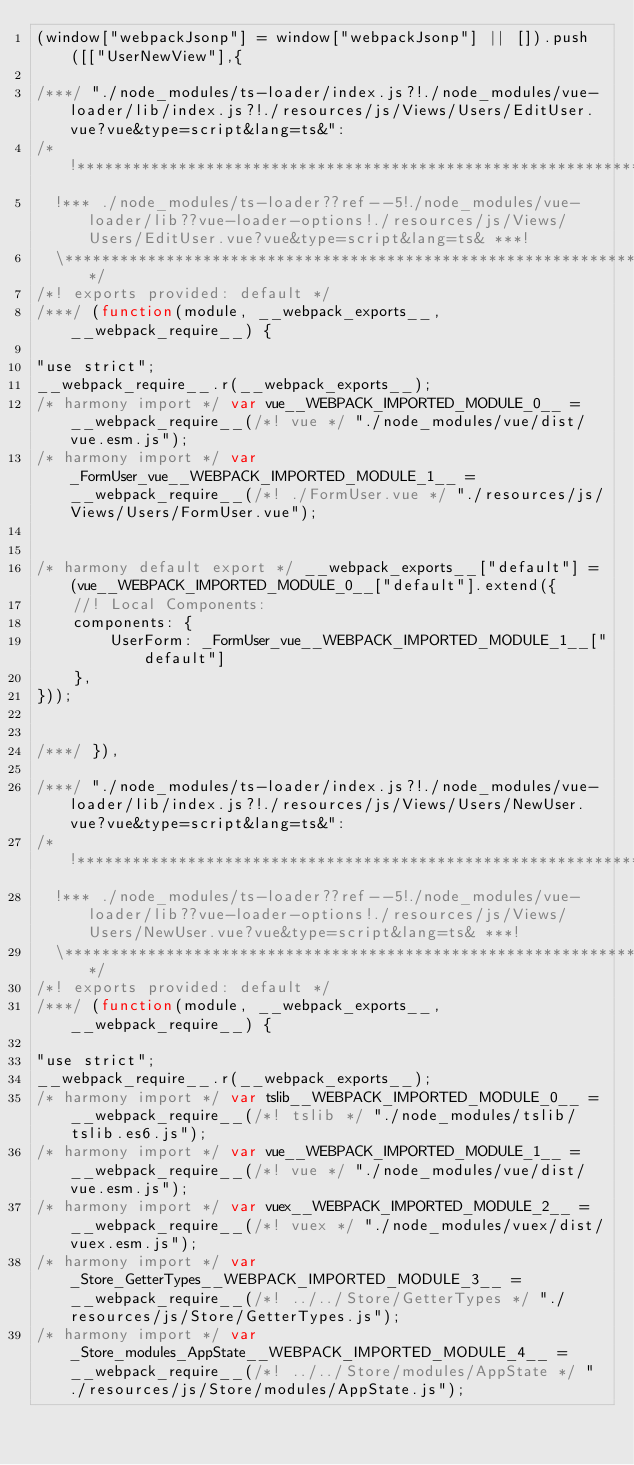Convert code to text. <code><loc_0><loc_0><loc_500><loc_500><_JavaScript_>(window["webpackJsonp"] = window["webpackJsonp"] || []).push([["UserNewView"],{

/***/ "./node_modules/ts-loader/index.js?!./node_modules/vue-loader/lib/index.js?!./resources/js/Views/Users/EditUser.vue?vue&type=script&lang=ts&":
/*!***********************************************************************************************************************************************************!*\
  !*** ./node_modules/ts-loader??ref--5!./node_modules/vue-loader/lib??vue-loader-options!./resources/js/Views/Users/EditUser.vue?vue&type=script&lang=ts& ***!
  \***********************************************************************************************************************************************************/
/*! exports provided: default */
/***/ (function(module, __webpack_exports__, __webpack_require__) {

"use strict";
__webpack_require__.r(__webpack_exports__);
/* harmony import */ var vue__WEBPACK_IMPORTED_MODULE_0__ = __webpack_require__(/*! vue */ "./node_modules/vue/dist/vue.esm.js");
/* harmony import */ var _FormUser_vue__WEBPACK_IMPORTED_MODULE_1__ = __webpack_require__(/*! ./FormUser.vue */ "./resources/js/Views/Users/FormUser.vue");


/* harmony default export */ __webpack_exports__["default"] = (vue__WEBPACK_IMPORTED_MODULE_0__["default"].extend({
    //! Local Components: 
    components: {
        UserForm: _FormUser_vue__WEBPACK_IMPORTED_MODULE_1__["default"]
    },
}));


/***/ }),

/***/ "./node_modules/ts-loader/index.js?!./node_modules/vue-loader/lib/index.js?!./resources/js/Views/Users/NewUser.vue?vue&type=script&lang=ts&":
/*!**********************************************************************************************************************************************************!*\
  !*** ./node_modules/ts-loader??ref--5!./node_modules/vue-loader/lib??vue-loader-options!./resources/js/Views/Users/NewUser.vue?vue&type=script&lang=ts& ***!
  \**********************************************************************************************************************************************************/
/*! exports provided: default */
/***/ (function(module, __webpack_exports__, __webpack_require__) {

"use strict";
__webpack_require__.r(__webpack_exports__);
/* harmony import */ var tslib__WEBPACK_IMPORTED_MODULE_0__ = __webpack_require__(/*! tslib */ "./node_modules/tslib/tslib.es6.js");
/* harmony import */ var vue__WEBPACK_IMPORTED_MODULE_1__ = __webpack_require__(/*! vue */ "./node_modules/vue/dist/vue.esm.js");
/* harmony import */ var vuex__WEBPACK_IMPORTED_MODULE_2__ = __webpack_require__(/*! vuex */ "./node_modules/vuex/dist/vuex.esm.js");
/* harmony import */ var _Store_GetterTypes__WEBPACK_IMPORTED_MODULE_3__ = __webpack_require__(/*! ../../Store/GetterTypes */ "./resources/js/Store/GetterTypes.js");
/* harmony import */ var _Store_modules_AppState__WEBPACK_IMPORTED_MODULE_4__ = __webpack_require__(/*! ../../Store/modules/AppState */ "./resources/js/Store/modules/AppState.js");</code> 